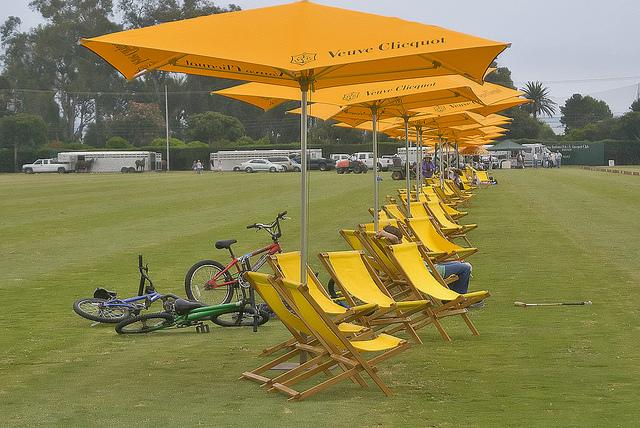The sporting event taking place on the grounds is most likely which one?

Choices:
A) golf
B) swimming
C) tennis
D) cycling golf 